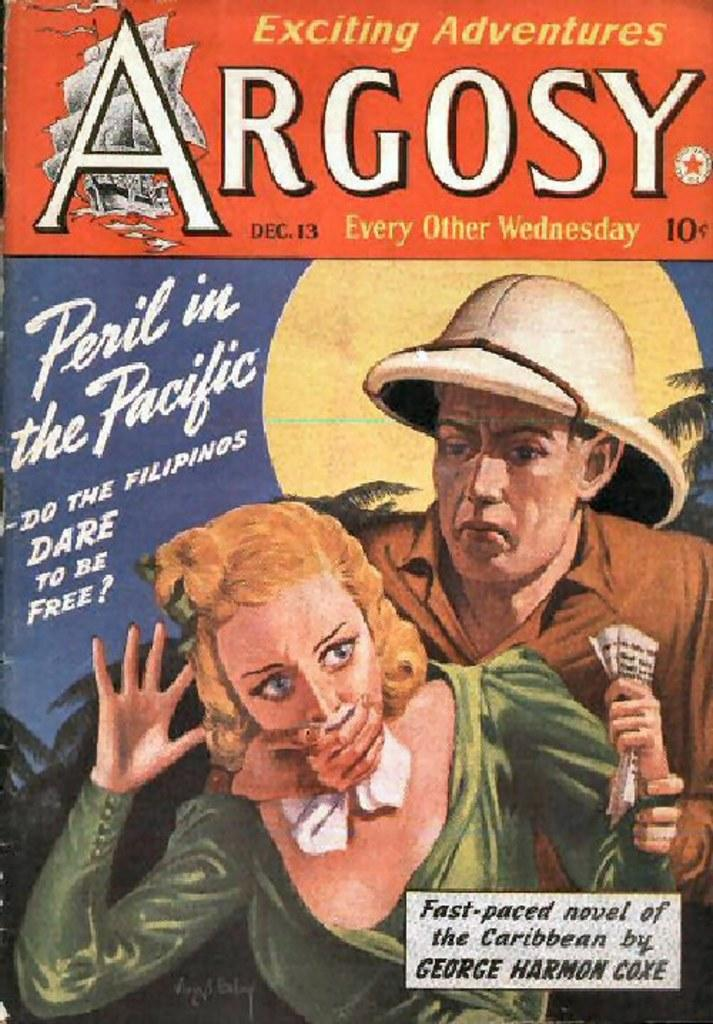What is the main subject of the image? The main subject of the image is the cover photo of a book. What is happening in the cover photo? In the cover photo, a man is holding a woman, and he is covering her face. What word is written on the cover of the book? The word "Argosy" is written on the cover. What type of ice can be seen melting on the engine in the image? There is no ice or engine present in the image; it features a cover photo of a book. Can you tell me how many parents are visible in the image? There are no parents depicted in the image; it features a man and a woman in a cover photo. 